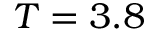<formula> <loc_0><loc_0><loc_500><loc_500>T = 3 . 8</formula> 